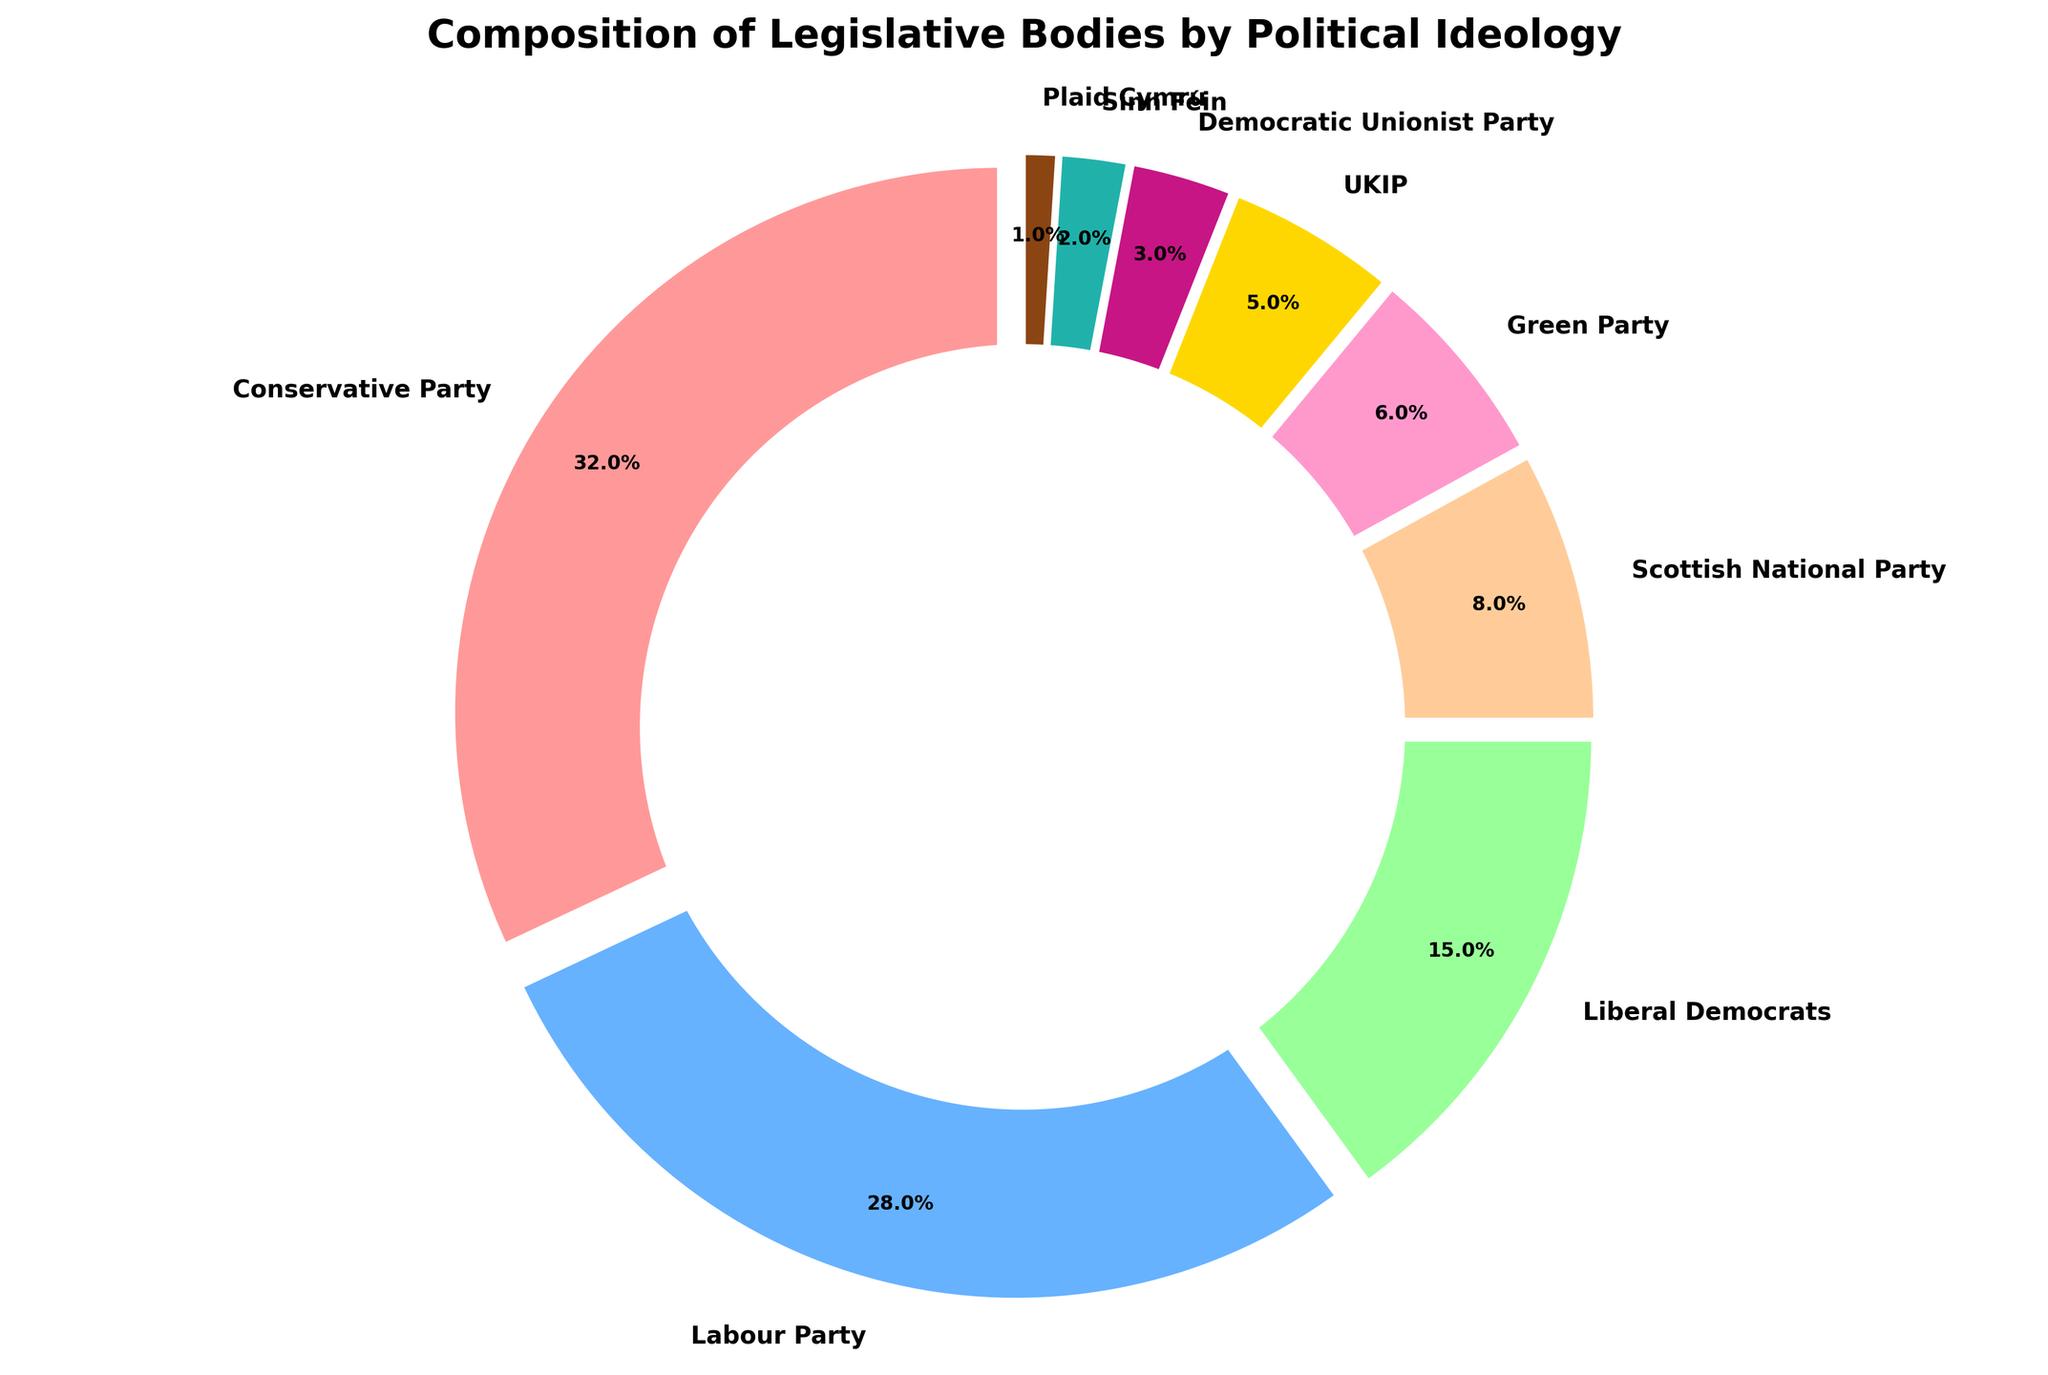What's the combined percentage of the Conservative Party and the Labour Party? To find the combined percentage, add the percentage of the Conservative Party (32%) to that of the Labour Party (28%): 32 + 28 = 60
Answer: 60% Which party has the smallest representation in the legislative bodies? The party with the smallest percentage is Plaid Cymru with 1%
Answer: Plaid Cymru How much larger is the percentage of the Conservative Party compared to the UKIP? Subtract the percentage of the UKIP (5%) from the percentage of the Conservative Party (32%): 32 - 5 = 27
Answer: 27% Which party has the closest percentage to the Green Party? The Green Party has 6%. Comparing this to other parties, the UKIP is closest with 5%.
Answer: UKIP What is the difference in percentage between the Labour Party and the Liberal Democrats? Subtract the percentage of the Liberal Democrats (15%) from the percentage of the Labour Party (28%): 28 - 15 = 13
Answer: 13% What is the sum of the percentages of all parties except the Conservative Party and the Labour Party? First, sum all the percentages: 32 + 28 + 15 + 8 + 6 + 5 + 3 + 2 + 1 = 100. Then, subtract the sum of the Conservative and Labour Parties: 100 - 32 - 28 = 40
Answer: 40% How does the SNP's representation compare to the Green Party? The SNP has 8% whereas the Green Party has 6%. The SNP has a larger representation.
Answer: Larger Which two parties have a combined percentage exactly equal to the Conservative Party's percentage? The Conservative Party has 32%. Adding the Labour Party (28%) and the Green Party (6%) results in 28 + 6 = 34, which is not equal to 32. Adding the Labour Party (28%) and the UKIP (5%) results in 28 + 5 = 33, which is not equal to 32. Adding the Liberal Democrats (15%) and the SNP (8%) results in 15 + 8 = 23, which is not equal to 32. Finally, adding the Liberal Democrats (15%) and the Green Party (6%), SNP (8%), UKIP (5%) results in 15 + 6 + 8 + 5 = 34, which is also not equal to 32. There are no two parties that sum to 32.
Answer: None 